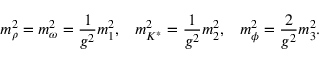<formula> <loc_0><loc_0><loc_500><loc_500>m _ { \rho } ^ { 2 } = m _ { \omega } ^ { 2 } = { \frac { 1 } { g ^ { 2 } } } m _ { 1 } ^ { 2 } , \, m _ { K ^ { * } } ^ { 2 } = { \frac { 1 } { g ^ { 2 } } } m _ { 2 } ^ { 2 } , \, m _ { \phi } ^ { 2 } = { \frac { 2 } { g ^ { 2 } } } m _ { 3 } ^ { 2 } .</formula> 